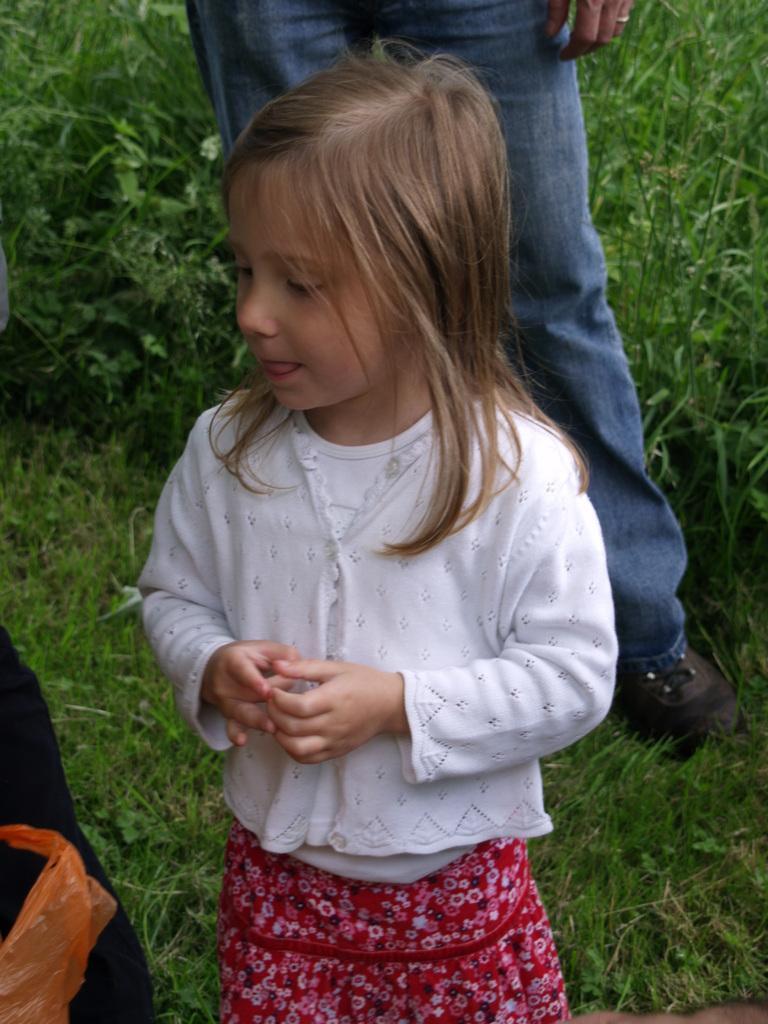Can you describe this image briefly? In the center of the image we can see one girl is standing and she is in white color top. On the left side of the image, we can see one black color object and one orange color plastic cover. In the background we can see the grass and one person standing. 